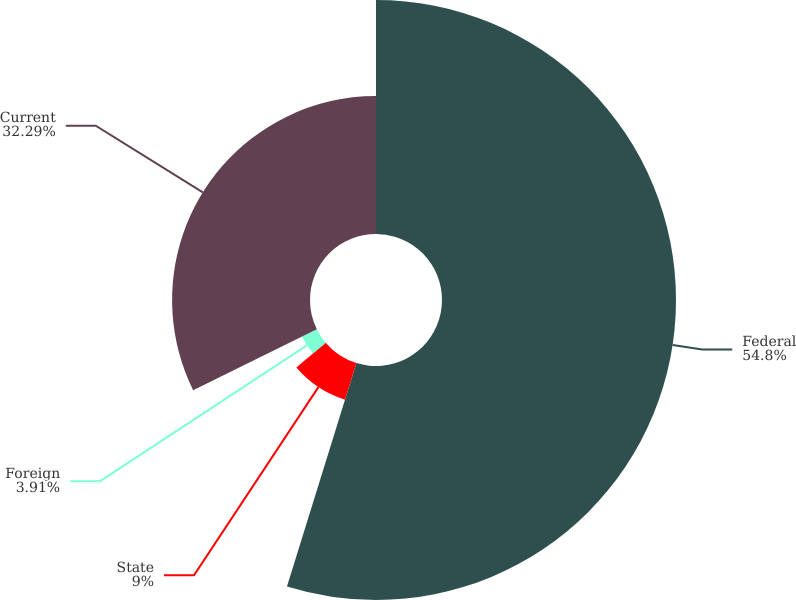<chart> <loc_0><loc_0><loc_500><loc_500><pie_chart><fcel>Federal<fcel>State<fcel>Foreign<fcel>Current<nl><fcel>54.79%<fcel>9.0%<fcel>3.91%<fcel>32.29%<nl></chart> 